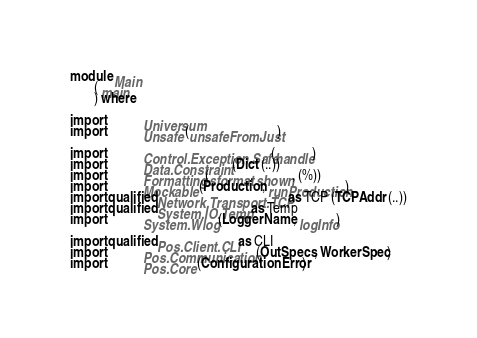<code> <loc_0><loc_0><loc_500><loc_500><_Haskell_>module Main
       ( main
       ) where

import           Universum
import           Unsafe (unsafeFromJust)

import           Control.Exception.Safe (handle)
import           Data.Constraint (Dict (..))
import           Formatting (sformat, shown, (%))
import           Mockable (Production, runProduction)
import qualified Network.Transport.TCP as TCP (TCPAddr (..))
import qualified System.IO.Temp as Temp
import           System.Wlog (LoggerName, logInfo)

import qualified Pos.Client.CLI as CLI
import           Pos.Communication (OutSpecs, WorkerSpec)
import           Pos.Core (ConfigurationError)</code> 